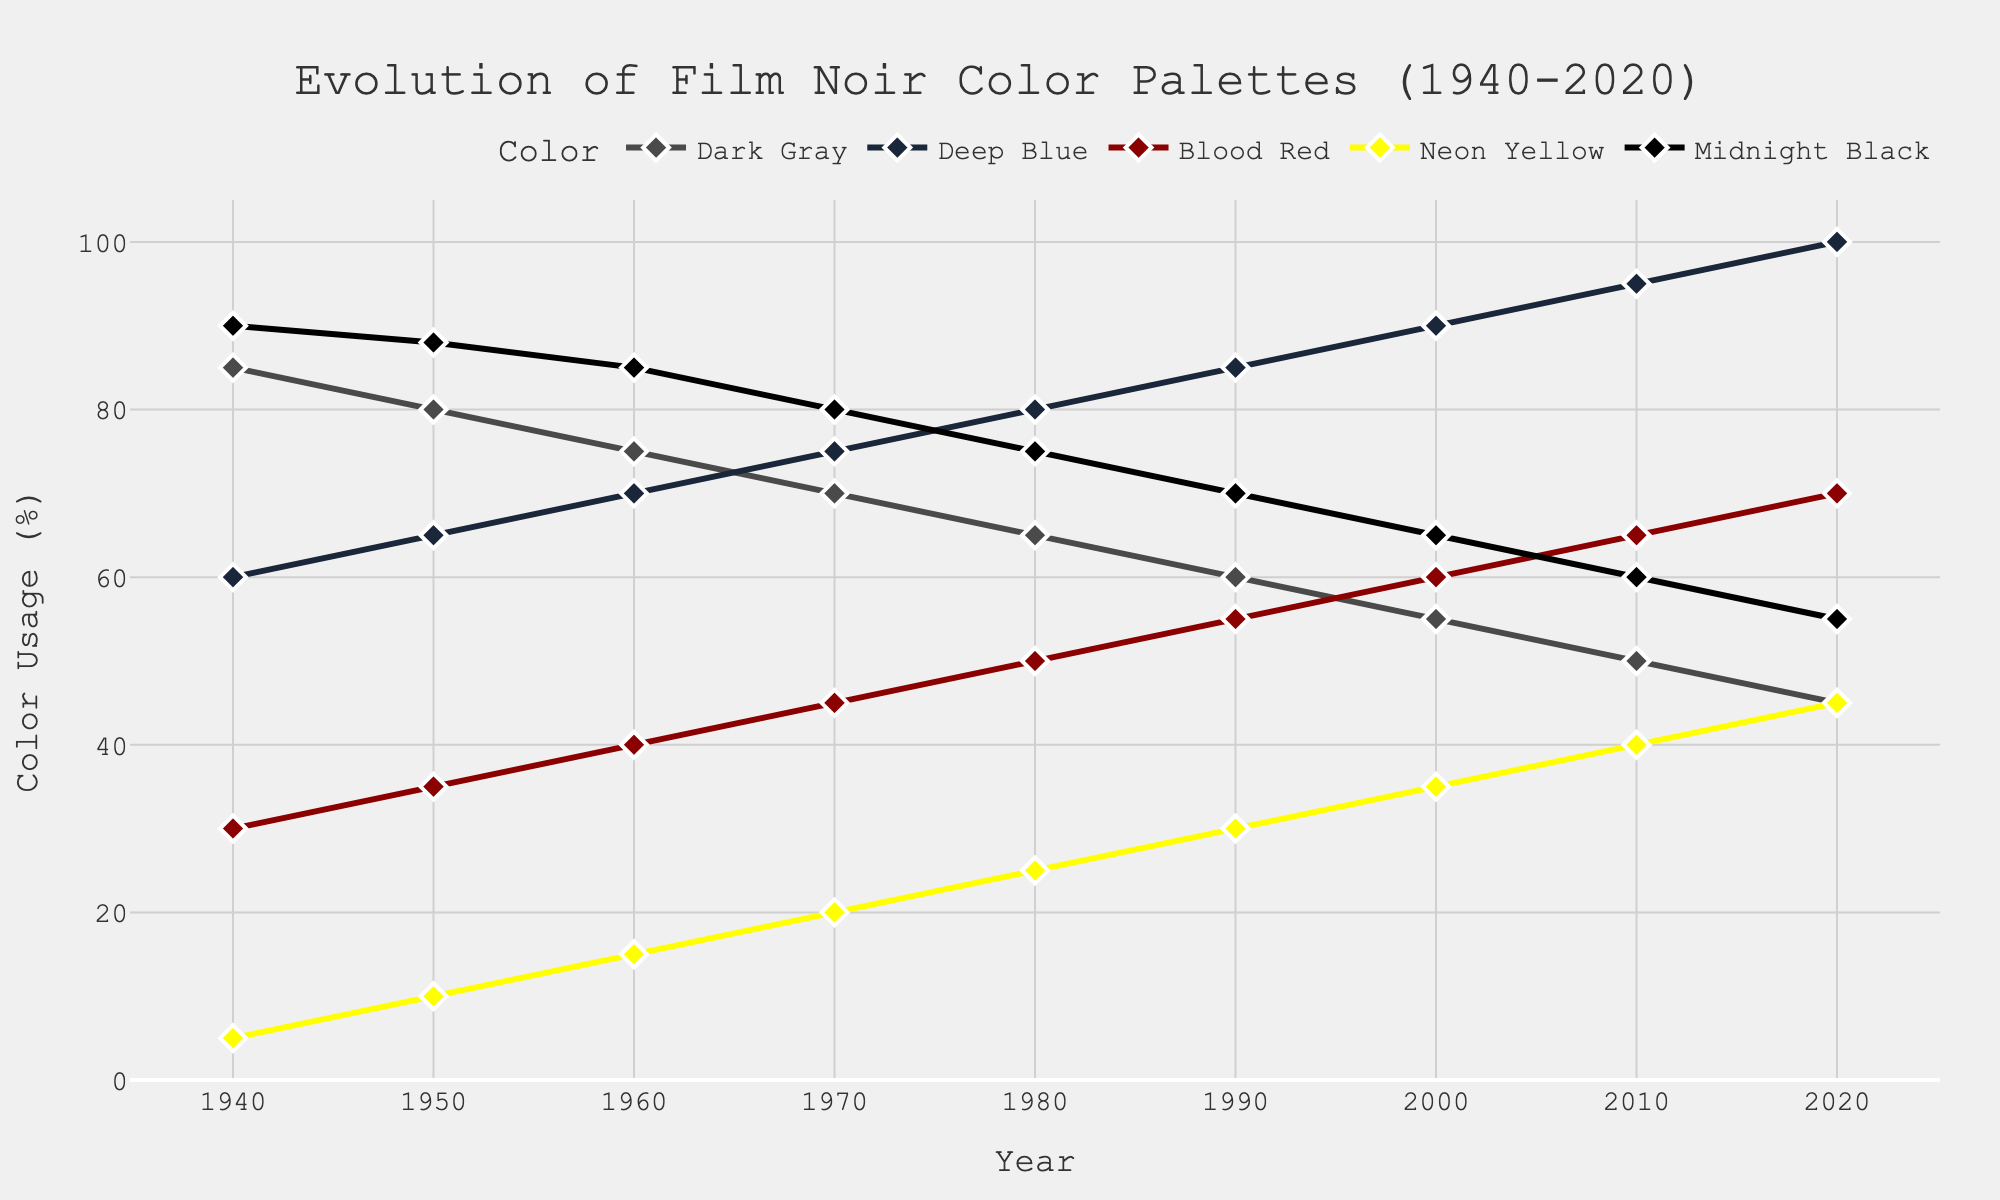What is the overall trend for the usage of Deep Blue from 1940 to 2020? The usage of Deep Blue shows an increasing trend over the years. It starts at 60% in 1940 and rises consistently, reaching 100% in 2020.
Answer: Increasing Which color saw the greatest decrease in usage from 1940 to 2020? By comparing the usage percentages in 1940 and 2020 for each color, Dark Gray had the greatest decrease, dropping from 85% to 45%, which is a change of 40%.
Answer: Dark Gray In which decade did Blood Red usage increase the most? To find this, look at the change in Blood Red usage from one decade to the next. The biggest increase is from 1980 to 1990, where it jumps from 50% to 55%, a change of 5%.
Answer: 1980s What is the average usage percentage of Midnight Black over the 80 years? Sum all the percentages of Midnight Black for each year and then divide by the number of years: (90 + 88 + 85 + 80 + 75 + 70 + 65 + 60 + 55) / 9 = 74.25%.
Answer: 74.25% Which two colors have the closest usage percentage in the year 2000? By comparing the usage percentages of all colors in the year 2000, Deep Blue is at 90% and Dark Gray is at 55%. The closest values are Blood Red at 60% and Neon Yellow at 35%, with a difference of 25%.
Answer: Blood Red and Dark Gray How does the usage of Neon Yellow change from 1940 to 2010? To determine the change, subtract the 1940 value from the 2010 value: 40% - 5% = 35%. Neon Yellow's usage increased by 35% from 1940 to 2010.
Answer: Increased by 35% What is the visual pattern of markers used in the plot? The plot uses diamond-shaped markers for all data points, outlined in white. Each color trace uses these markers to help distinguish individual data points.
Answer: Diamond-shaped, white outline Compare the usage percentage of Midnight Black and Dark Gray in 1980. Which is higher? In 1980, the usage of Midnight Black is 75%, and Dark Gray is 65%. Midnight Black has a higher percentage than Dark Gray.
Answer: Midnight Black Is there any year when Dark Gray usage was equal to Deep Blue usage? By examining each year's data, Dark Gray and Deep Blue do not have the same usage percentage in any given year.
Answer: No Calculate the total change in Blood Red usage from 1940 to 2000. The Blood Red usage in 1940 is 30% and in 2000 is 60%. The total change is 60% - 30% = 30%.
Answer: 30% 